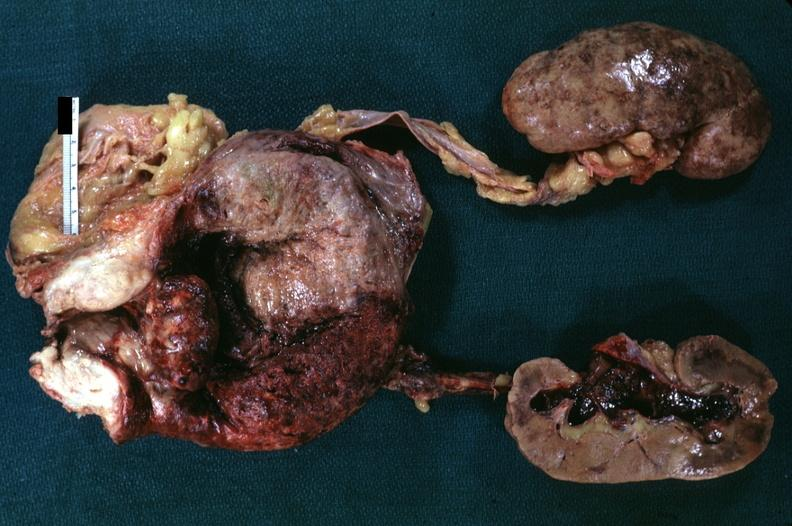what does this image show?
Answer the question using a single word or phrase. That median lobe hyperplasia with marked cystitis and bladder hypertrophy ureter appear normal focal hemorrhages in kidneys and hemorrhagic pyelitis indicates pyelonephritis carcinoma in prostate is diagnosis but can not 